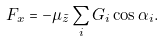Convert formula to latex. <formula><loc_0><loc_0><loc_500><loc_500>F _ { x } = - \mu _ { \tilde { z } } \sum _ { i } G _ { i } \cos \alpha _ { i } .</formula> 